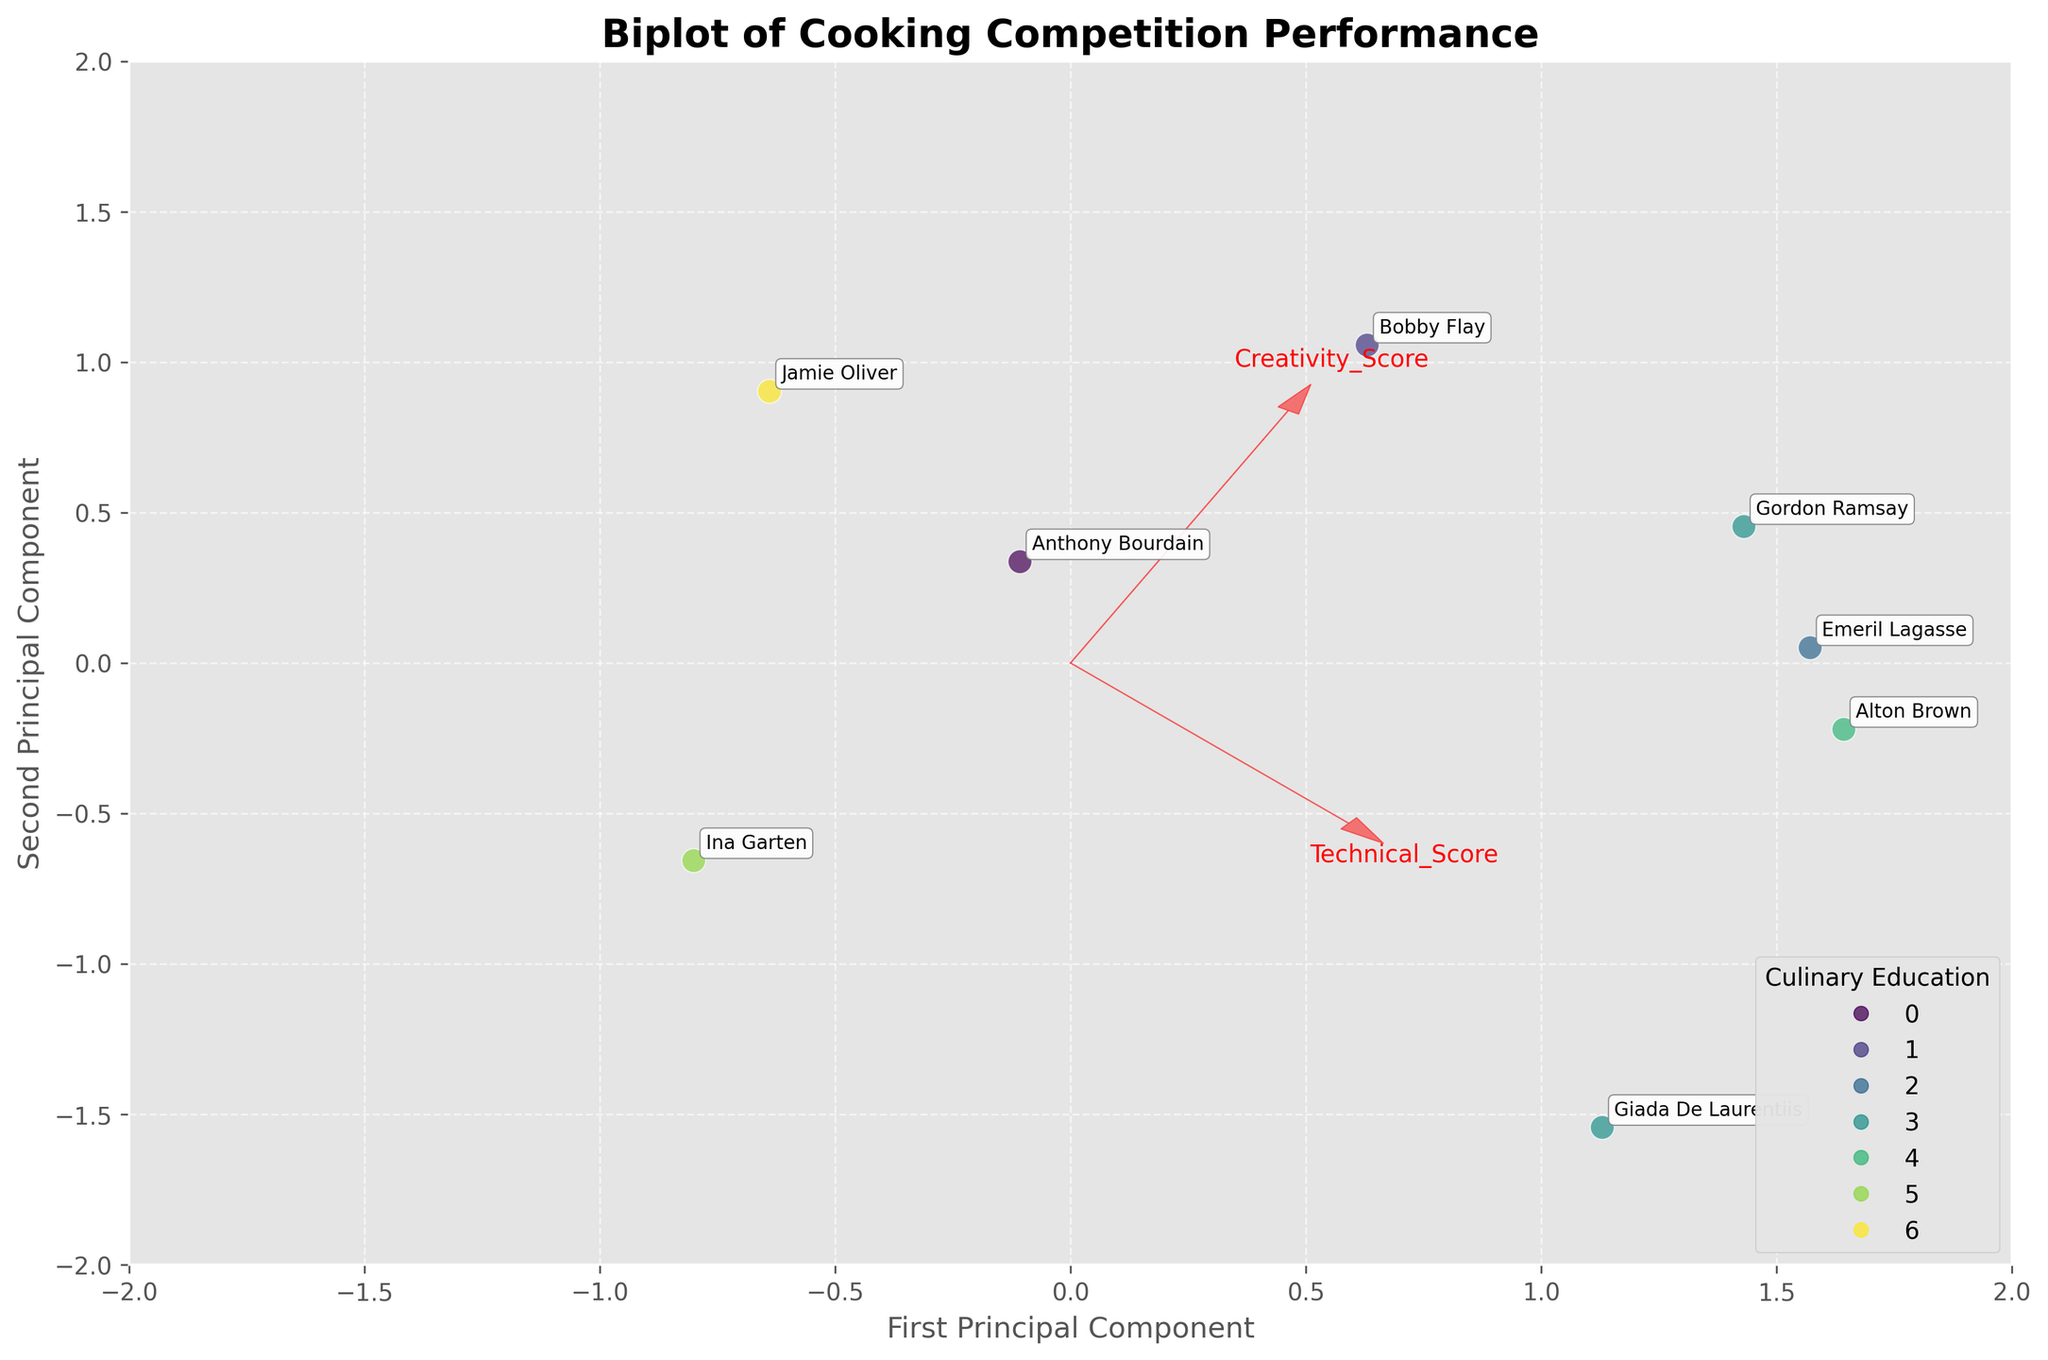How many unique culinary education backgrounds are represented in the plot? To determine the number of unique culinary education backgrounds, observe the legend on the bottom right that categorizes the data points by different colors, each representing a unique culinary education background.
Answer: 6 Which feature has the most influence on the first principal component? In a biplot, the length and direction of the arrows indicate the influence of features. The arrow pointing the furthest along the x-axis (first principal component) identifies the most influential feature. By observing the plot, 'Technical_Score' has the longest arrow aligned with the first principal component.
Answer: Technical_Score Who are the contestants with the highest Creativity Score? To find contestants with the highest Creativity Score, look at the feature vector for 'Creativity_Score' and track the contestants positioned furthest in that direction. The plot shows that Jamie Oliver and Nigella Lawson are closest to this vector.
Answer: Jamie Oliver and Nigella Lawson How is Gordon Ramsay positioned in terms of Time Management compared to Ina Garten? 'Time Management' direction is indicated by one of the feature vectors. By comparing Gordon Ramsay and Ina Garten in the direction of this vector, Ramsay appears to be positioned further along the 'Time Management' vector.
Answer: Gordon Ramsay is better positioned in terms of Time Management What does a point near the origin of the biplot represent? Points near the origin of the biplot indicate that the contestant's scores (across the plotted features) are close to the average for all contestants, as the origin represents the mean of all features after standardization. Therefore, all feature scores for these contestants do not significantly deviate from the average.
Answer: Close-to-average performance across all features Which contestant has their principal component values most influenced by the Creativity Score? Determine the contestant whose position aligns closely with the 'Creativity_Score' vector's direction and magnitude. Jamie Oliver is positioned the furthest along the 'Creativity_Score' vector, indicating a high influence of this feature on his principal component values.
Answer: Jamie Oliver Are self-taught chefs clustered together in the biplot? Review the scatter plot to see the distribution of the points coded with the same color representing 'Self-Taught' chefs. The points representing Self-Taught chefs (Rachael Ray, Ina Garten, Nigella Lawson) are somewhat dispersed rather than tightly clustered.
Answer: No, they are not tightly clustered What does an arrow's direction and length indicate on a biplot? An arrow's direction and length show the correlation and influence of the original features on the principal components. The direction indicates the axis the feature is aligned with, and the length shows the strength of its influence. Longer arrows signify stronger contributions to the principal components, and the direction shows the relationship to the components.
Answer: Correlation and influence of features on principal components Which contestant is closest to the average scores in all three features? Contestants closest to the origin (0,0) in the biplot have principal component scores close to the average. Check the annotations for those points near the origin. Alton Brown and Giada De Laurentiis are closest to the origin, suggesting their scores are near average.
Answer: Alton Brown and Giada De Laurentiis 